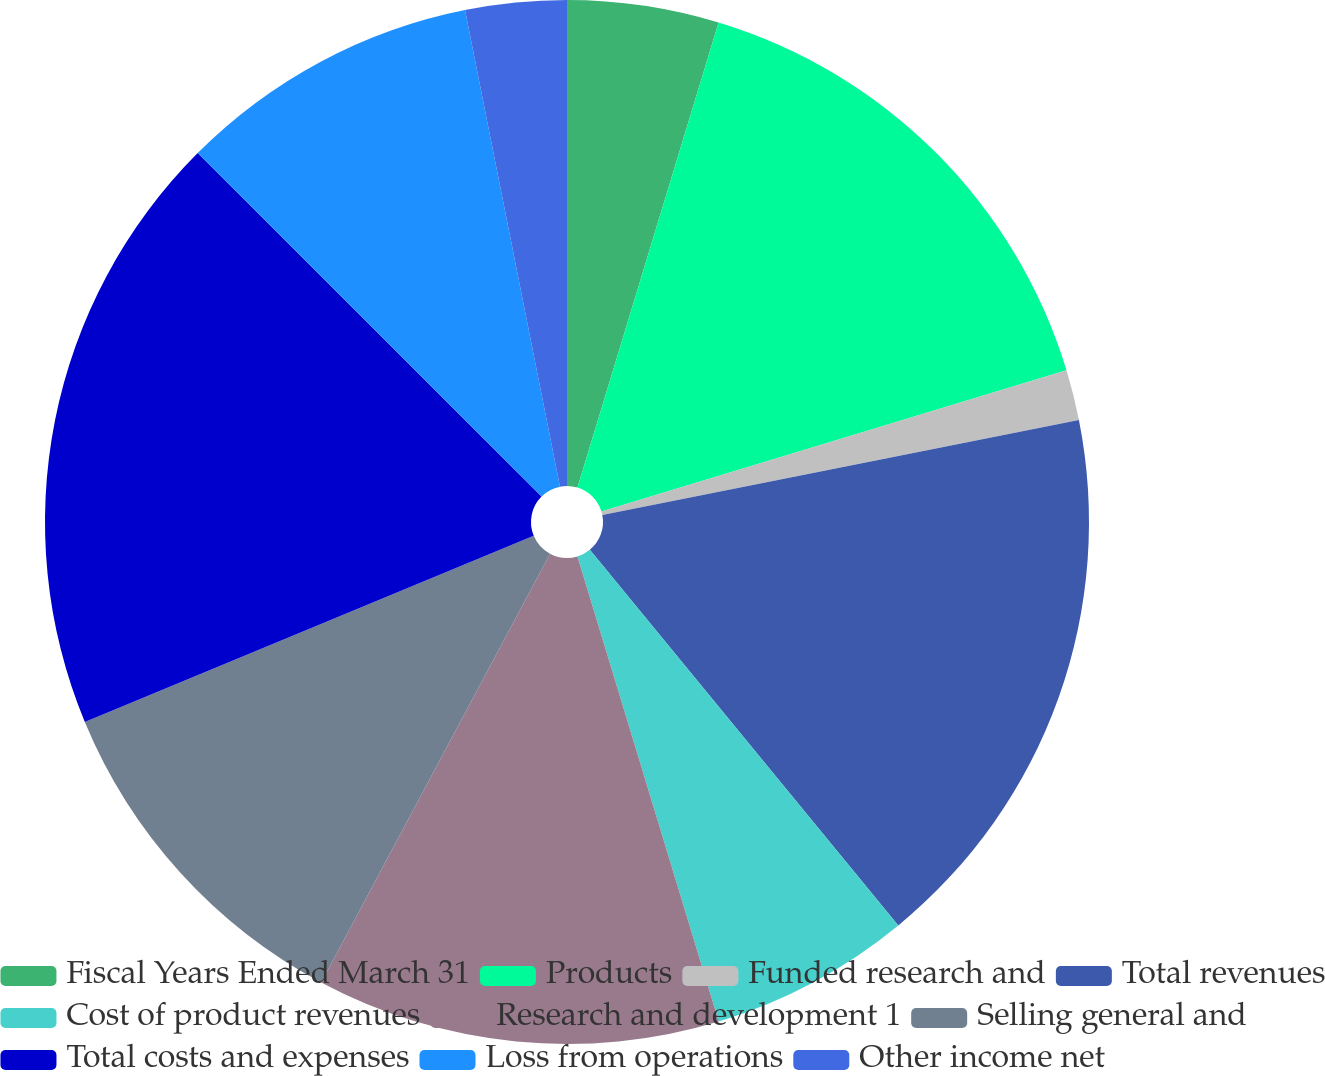Convert chart. <chart><loc_0><loc_0><loc_500><loc_500><pie_chart><fcel>Fiscal Years Ended March 31<fcel>Products<fcel>Funded research and<fcel>Total revenues<fcel>Cost of product revenues<fcel>Research and development 1<fcel>Selling general and<fcel>Total costs and expenses<fcel>Loss from operations<fcel>Other income net<nl><fcel>4.69%<fcel>15.62%<fcel>1.56%<fcel>17.19%<fcel>6.25%<fcel>12.5%<fcel>10.94%<fcel>18.75%<fcel>9.38%<fcel>3.13%<nl></chart> 